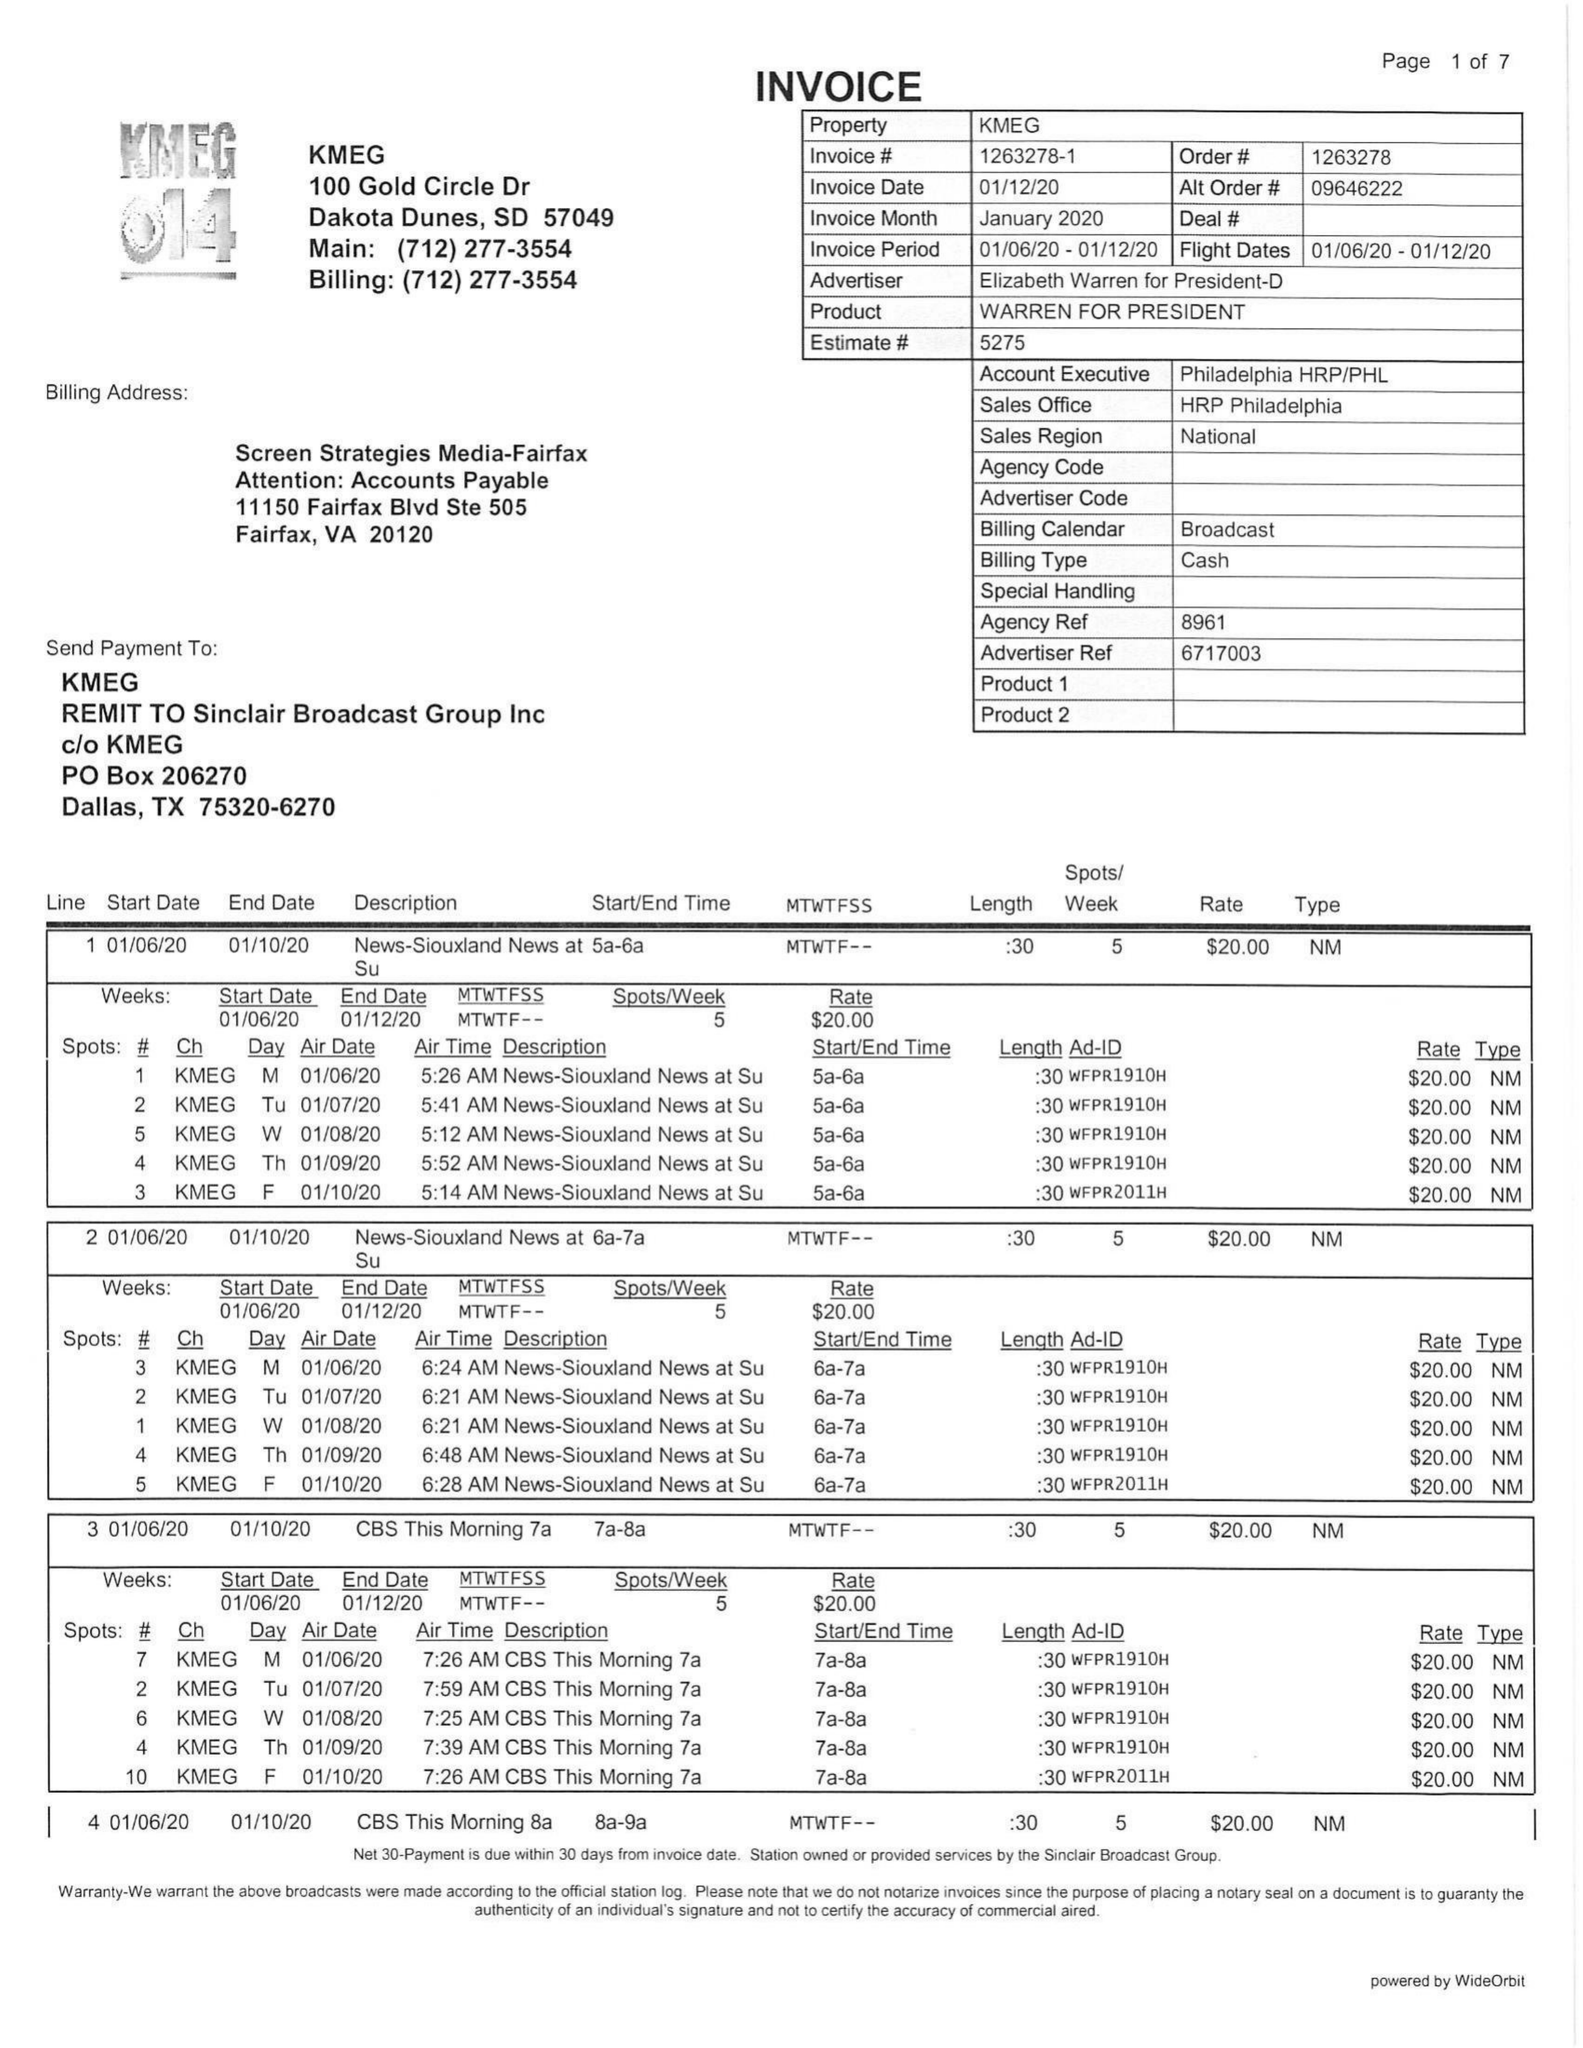What is the value for the advertiser?
Answer the question using a single word or phrase. ELIZABETH WARREN FOR PRESIDENT-D 